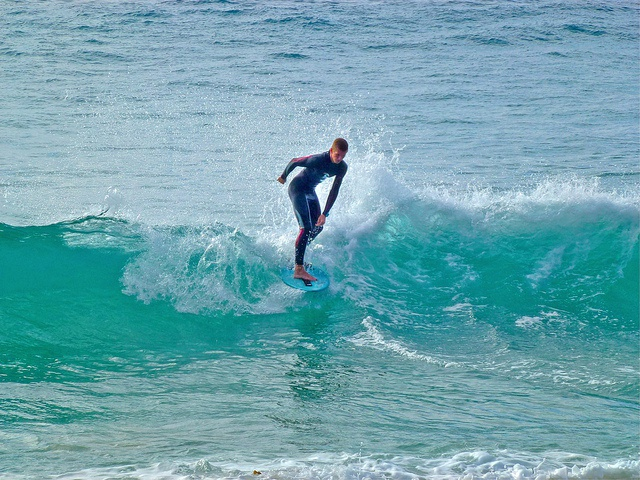Describe the objects in this image and their specific colors. I can see people in lightblue, navy, white, and gray tones and surfboard in lightblue and teal tones in this image. 